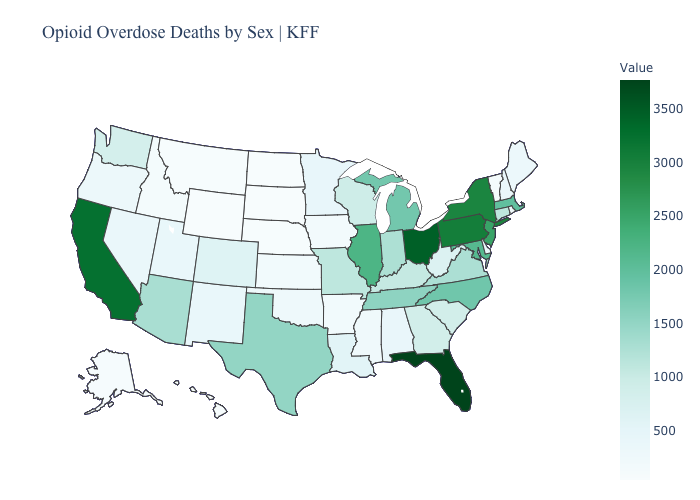Which states have the lowest value in the USA?
Answer briefly. South Dakota. Among the states that border South Dakota , which have the highest value?
Be succinct. Minnesota. Does Alaska have the highest value in the USA?
Give a very brief answer. No. Does Alaska have a lower value than Maryland?
Concise answer only. Yes. 